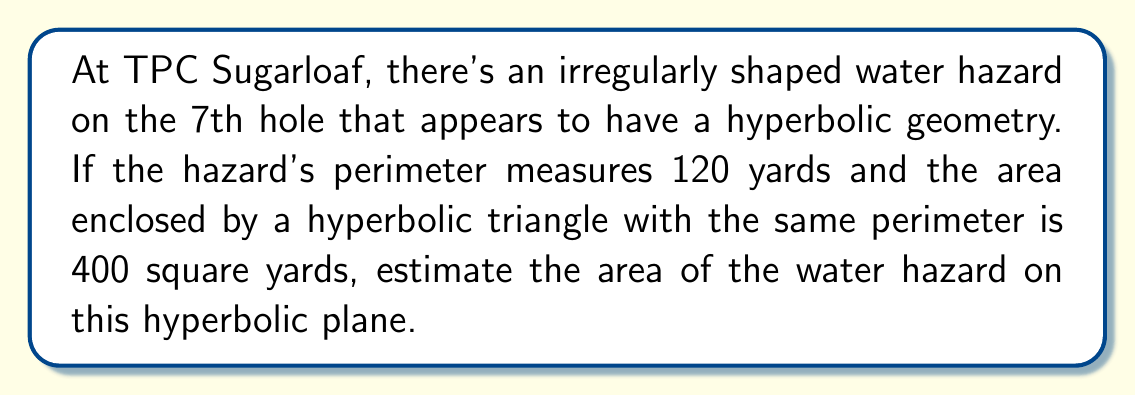Could you help me with this problem? To estimate the area of the irregularly shaped water hazard on a hyperbolic plane, we'll use the following steps:

1) In hyperbolic geometry, the area of a shape is often compared to the area of a regular polygon with the same perimeter. In this case, we're given information about a hyperbolic triangle.

2) The isoperimetric inequality in hyperbolic geometry states that among all shapes with a given perimeter, the regular polygon has the maximum area.

3) Let's denote the area of our irregular water hazard as $A$ and its perimeter as $p$. We know that $p = 120$ yards.

4) The area of a hyperbolic triangle with perimeter $p$ is given by:

   $$A_{triangle} = \pi - \alpha - \beta - \gamma$$

   where $\alpha$, $\beta$, and $\gamma$ are the angles of the triangle.

5) We're told that this area is 400 square yards. So:

   $$400 = \pi - \alpha - \beta - \gamma$$

6) The irregular shape will have an area less than or equal to the triangle:

   $$A \leq 400$$

7) To get a more precise estimate, we can use the fact that most golf course water hazards are roughly elliptical. In hyperbolic geometry, the area of an ellipse-like shape is typically about 80-90% of the area of a triangle with the same perimeter.

8) Let's estimate conservatively at 80%:

   $$A \approx 0.8 \times 400 = 320$$

Therefore, we can estimate the area of the water hazard to be approximately 320 square yards.
Answer: $320$ square yards 